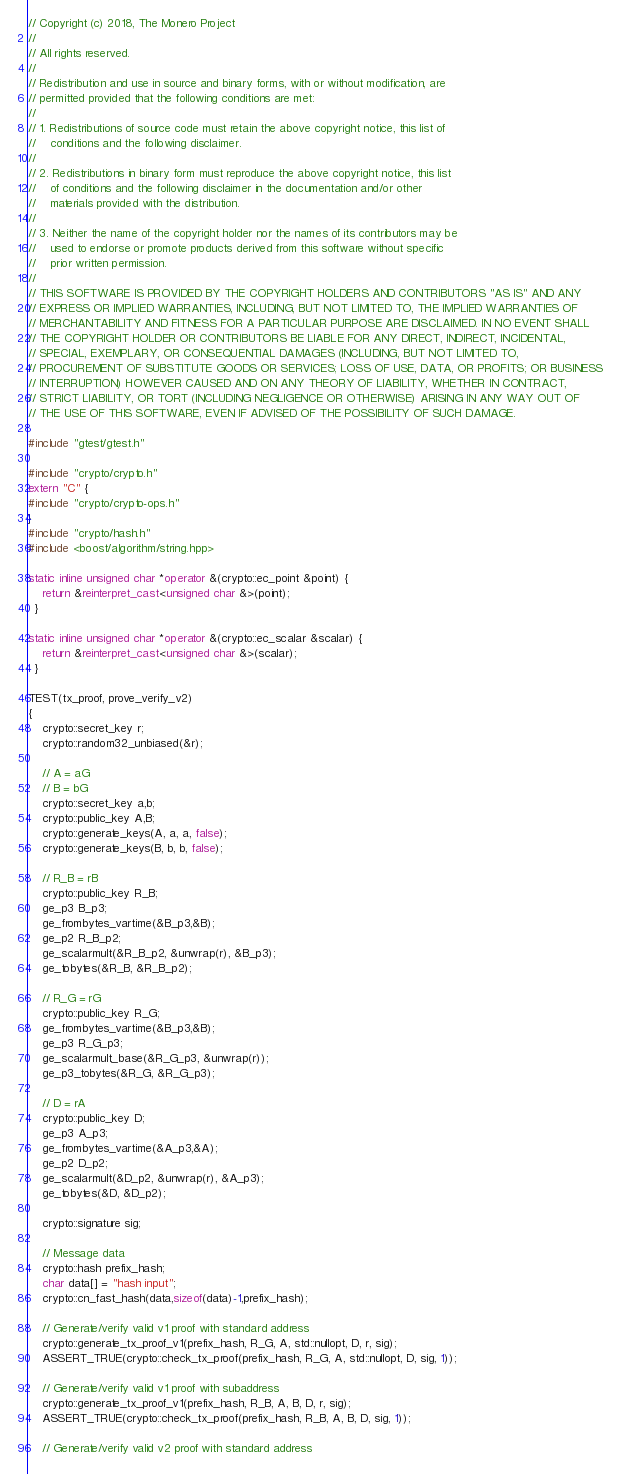<code> <loc_0><loc_0><loc_500><loc_500><_C++_>// Copyright (c) 2018, The Monero Project
//
// All rights reserved.
//
// Redistribution and use in source and binary forms, with or without modification, are
// permitted provided that the following conditions are met:
//
// 1. Redistributions of source code must retain the above copyright notice, this list of
//    conditions and the following disclaimer.
//
// 2. Redistributions in binary form must reproduce the above copyright notice, this list
//    of conditions and the following disclaimer in the documentation and/or other
//    materials provided with the distribution.
//
// 3. Neither the name of the copyright holder nor the names of its contributors may be
//    used to endorse or promote products derived from this software without specific
//    prior written permission.
//
// THIS SOFTWARE IS PROVIDED BY THE COPYRIGHT HOLDERS AND CONTRIBUTORS "AS IS" AND ANY
// EXPRESS OR IMPLIED WARRANTIES, INCLUDING, BUT NOT LIMITED TO, THE IMPLIED WARRANTIES OF
// MERCHANTABILITY AND FITNESS FOR A PARTICULAR PURPOSE ARE DISCLAIMED. IN NO EVENT SHALL
// THE COPYRIGHT HOLDER OR CONTRIBUTORS BE LIABLE FOR ANY DIRECT, INDIRECT, INCIDENTAL,
// SPECIAL, EXEMPLARY, OR CONSEQUENTIAL DAMAGES (INCLUDING, BUT NOT LIMITED TO,
// PROCUREMENT OF SUBSTITUTE GOODS OR SERVICES; LOSS OF USE, DATA, OR PROFITS; OR BUSINESS
// INTERRUPTION) HOWEVER CAUSED AND ON ANY THEORY OF LIABILITY, WHETHER IN CONTRACT,
// STRICT LIABILITY, OR TORT (INCLUDING NEGLIGENCE OR OTHERWISE) ARISING IN ANY WAY OUT OF
// THE USE OF THIS SOFTWARE, EVEN IF ADVISED OF THE POSSIBILITY OF SUCH DAMAGE.

#include "gtest/gtest.h"

#include "crypto/crypto.h"
extern "C" {
#include "crypto/crypto-ops.h"
}
#include "crypto/hash.h"
#include <boost/algorithm/string.hpp>

static inline unsigned char *operator &(crypto::ec_point &point) {
    return &reinterpret_cast<unsigned char &>(point);
  }

static inline unsigned char *operator &(crypto::ec_scalar &scalar) {
    return &reinterpret_cast<unsigned char &>(scalar);
  }

TEST(tx_proof, prove_verify_v2)
{
    crypto::secret_key r;
    crypto::random32_unbiased(&r);

    // A = aG
    // B = bG
    crypto::secret_key a,b;
    crypto::public_key A,B;
    crypto::generate_keys(A, a, a, false);
    crypto::generate_keys(B, b, b, false);

    // R_B = rB
    crypto::public_key R_B;
    ge_p3 B_p3;
    ge_frombytes_vartime(&B_p3,&B);
    ge_p2 R_B_p2;
    ge_scalarmult(&R_B_p2, &unwrap(r), &B_p3);
    ge_tobytes(&R_B, &R_B_p2);

    // R_G = rG
    crypto::public_key R_G;
    ge_frombytes_vartime(&B_p3,&B);
    ge_p3 R_G_p3;
    ge_scalarmult_base(&R_G_p3, &unwrap(r));
    ge_p3_tobytes(&R_G, &R_G_p3);

    // D = rA
    crypto::public_key D;
    ge_p3 A_p3;
    ge_frombytes_vartime(&A_p3,&A);
    ge_p2 D_p2;
    ge_scalarmult(&D_p2, &unwrap(r), &A_p3);
    ge_tobytes(&D, &D_p2);

    crypto::signature sig;

    // Message data
    crypto::hash prefix_hash;
    char data[] = "hash input";
    crypto::cn_fast_hash(data,sizeof(data)-1,prefix_hash);

    // Generate/verify valid v1 proof with standard address
    crypto::generate_tx_proof_v1(prefix_hash, R_G, A, std::nullopt, D, r, sig);
    ASSERT_TRUE(crypto::check_tx_proof(prefix_hash, R_G, A, std::nullopt, D, sig, 1));

    // Generate/verify valid v1 proof with subaddress
    crypto::generate_tx_proof_v1(prefix_hash, R_B, A, B, D, r, sig);
    ASSERT_TRUE(crypto::check_tx_proof(prefix_hash, R_B, A, B, D, sig, 1));

    // Generate/verify valid v2 proof with standard address</code> 